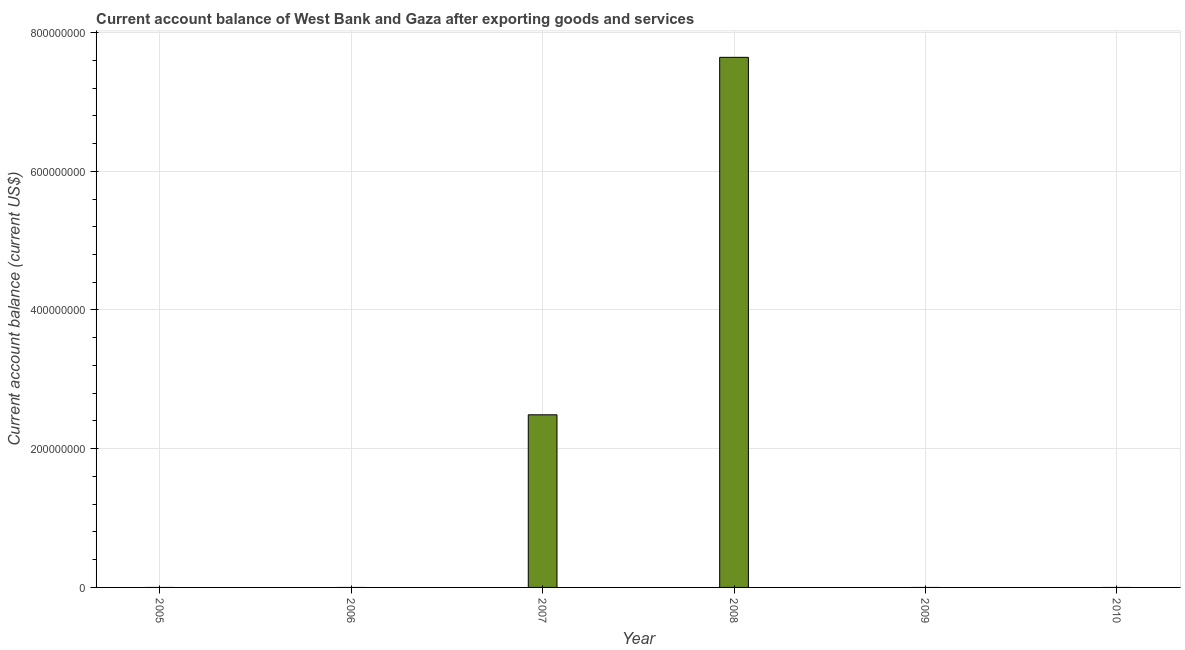What is the title of the graph?
Give a very brief answer. Current account balance of West Bank and Gaza after exporting goods and services. What is the label or title of the X-axis?
Offer a terse response. Year. What is the label or title of the Y-axis?
Your answer should be very brief. Current account balance (current US$). Across all years, what is the maximum current account balance?
Keep it short and to the point. 7.64e+08. In which year was the current account balance maximum?
Ensure brevity in your answer.  2008. What is the sum of the current account balance?
Ensure brevity in your answer.  1.01e+09. What is the average current account balance per year?
Give a very brief answer. 1.69e+08. What is the difference between the highest and the lowest current account balance?
Offer a very short reply. 7.64e+08. How many bars are there?
Your answer should be very brief. 2. Are all the bars in the graph horizontal?
Your answer should be compact. No. How many years are there in the graph?
Your answer should be compact. 6. What is the Current account balance (current US$) in 2005?
Ensure brevity in your answer.  0. What is the Current account balance (current US$) in 2007?
Provide a short and direct response. 2.49e+08. What is the Current account balance (current US$) of 2008?
Your answer should be very brief. 7.64e+08. What is the Current account balance (current US$) in 2009?
Keep it short and to the point. 0. What is the difference between the Current account balance (current US$) in 2007 and 2008?
Your response must be concise. -5.15e+08. What is the ratio of the Current account balance (current US$) in 2007 to that in 2008?
Your response must be concise. 0.33. 